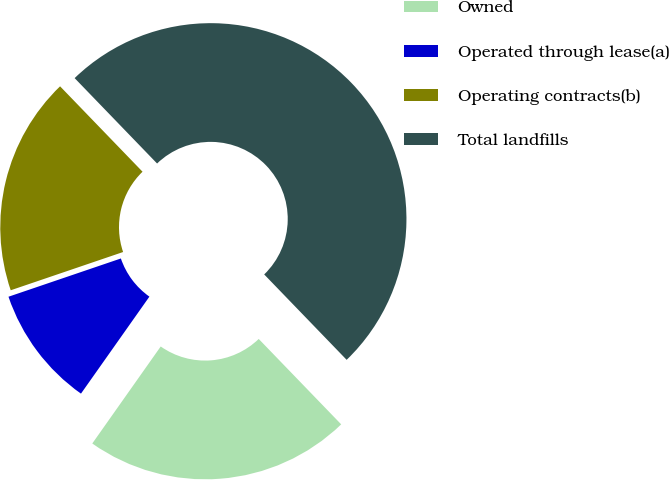Convert chart. <chart><loc_0><loc_0><loc_500><loc_500><pie_chart><fcel>Owned<fcel>Operated through lease(a)<fcel>Operating contracts(b)<fcel>Total landfills<nl><fcel>22.0%<fcel>10.0%<fcel>18.0%<fcel>50.0%<nl></chart> 